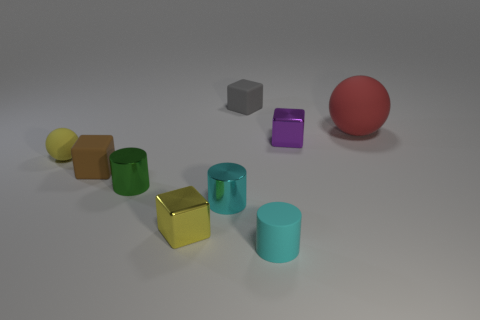There is a yellow rubber thing behind the brown matte object; is its size the same as the tiny gray thing?
Provide a short and direct response. Yes. Is there a large block that has the same color as the matte cylinder?
Your answer should be compact. No. What size is the red object that is the same material as the gray object?
Provide a short and direct response. Large. Are there more tiny yellow blocks in front of the cyan matte thing than tiny blocks behind the red object?
Give a very brief answer. No. What number of other objects are there of the same material as the large red thing?
Keep it short and to the point. 4. Are the ball on the right side of the yellow matte thing and the yellow ball made of the same material?
Ensure brevity in your answer.  Yes. The green thing has what shape?
Give a very brief answer. Cylinder. Are there more small metallic cylinders left of the tiny yellow metallic block than rubber cubes?
Your response must be concise. No. What color is the other small rubber thing that is the same shape as the tiny gray rubber thing?
Keep it short and to the point. Brown. The tiny yellow object on the right side of the brown cube has what shape?
Give a very brief answer. Cube. 